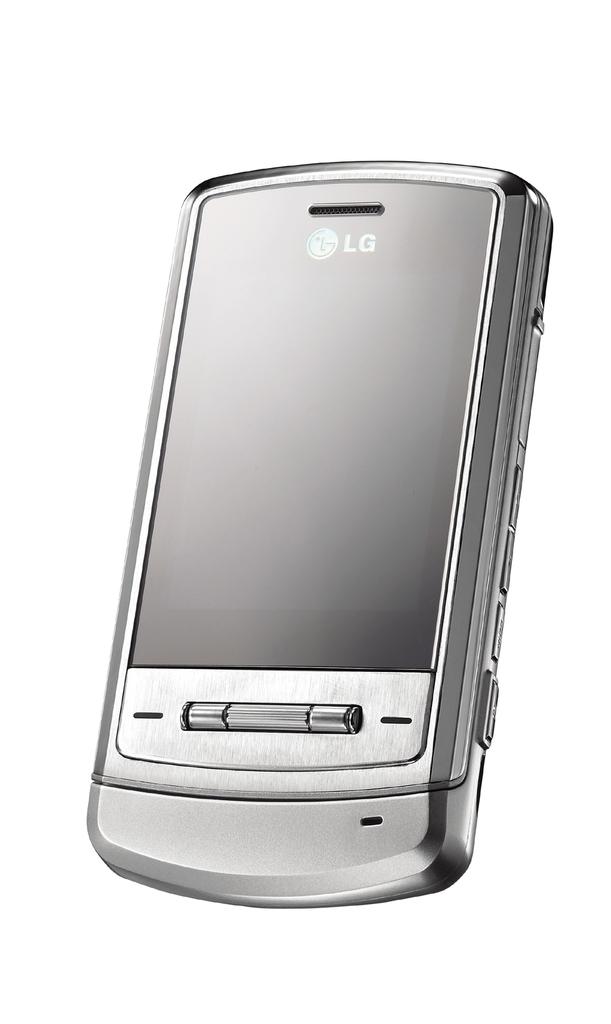What kind of phone is this?
Provide a succinct answer. Lg. 